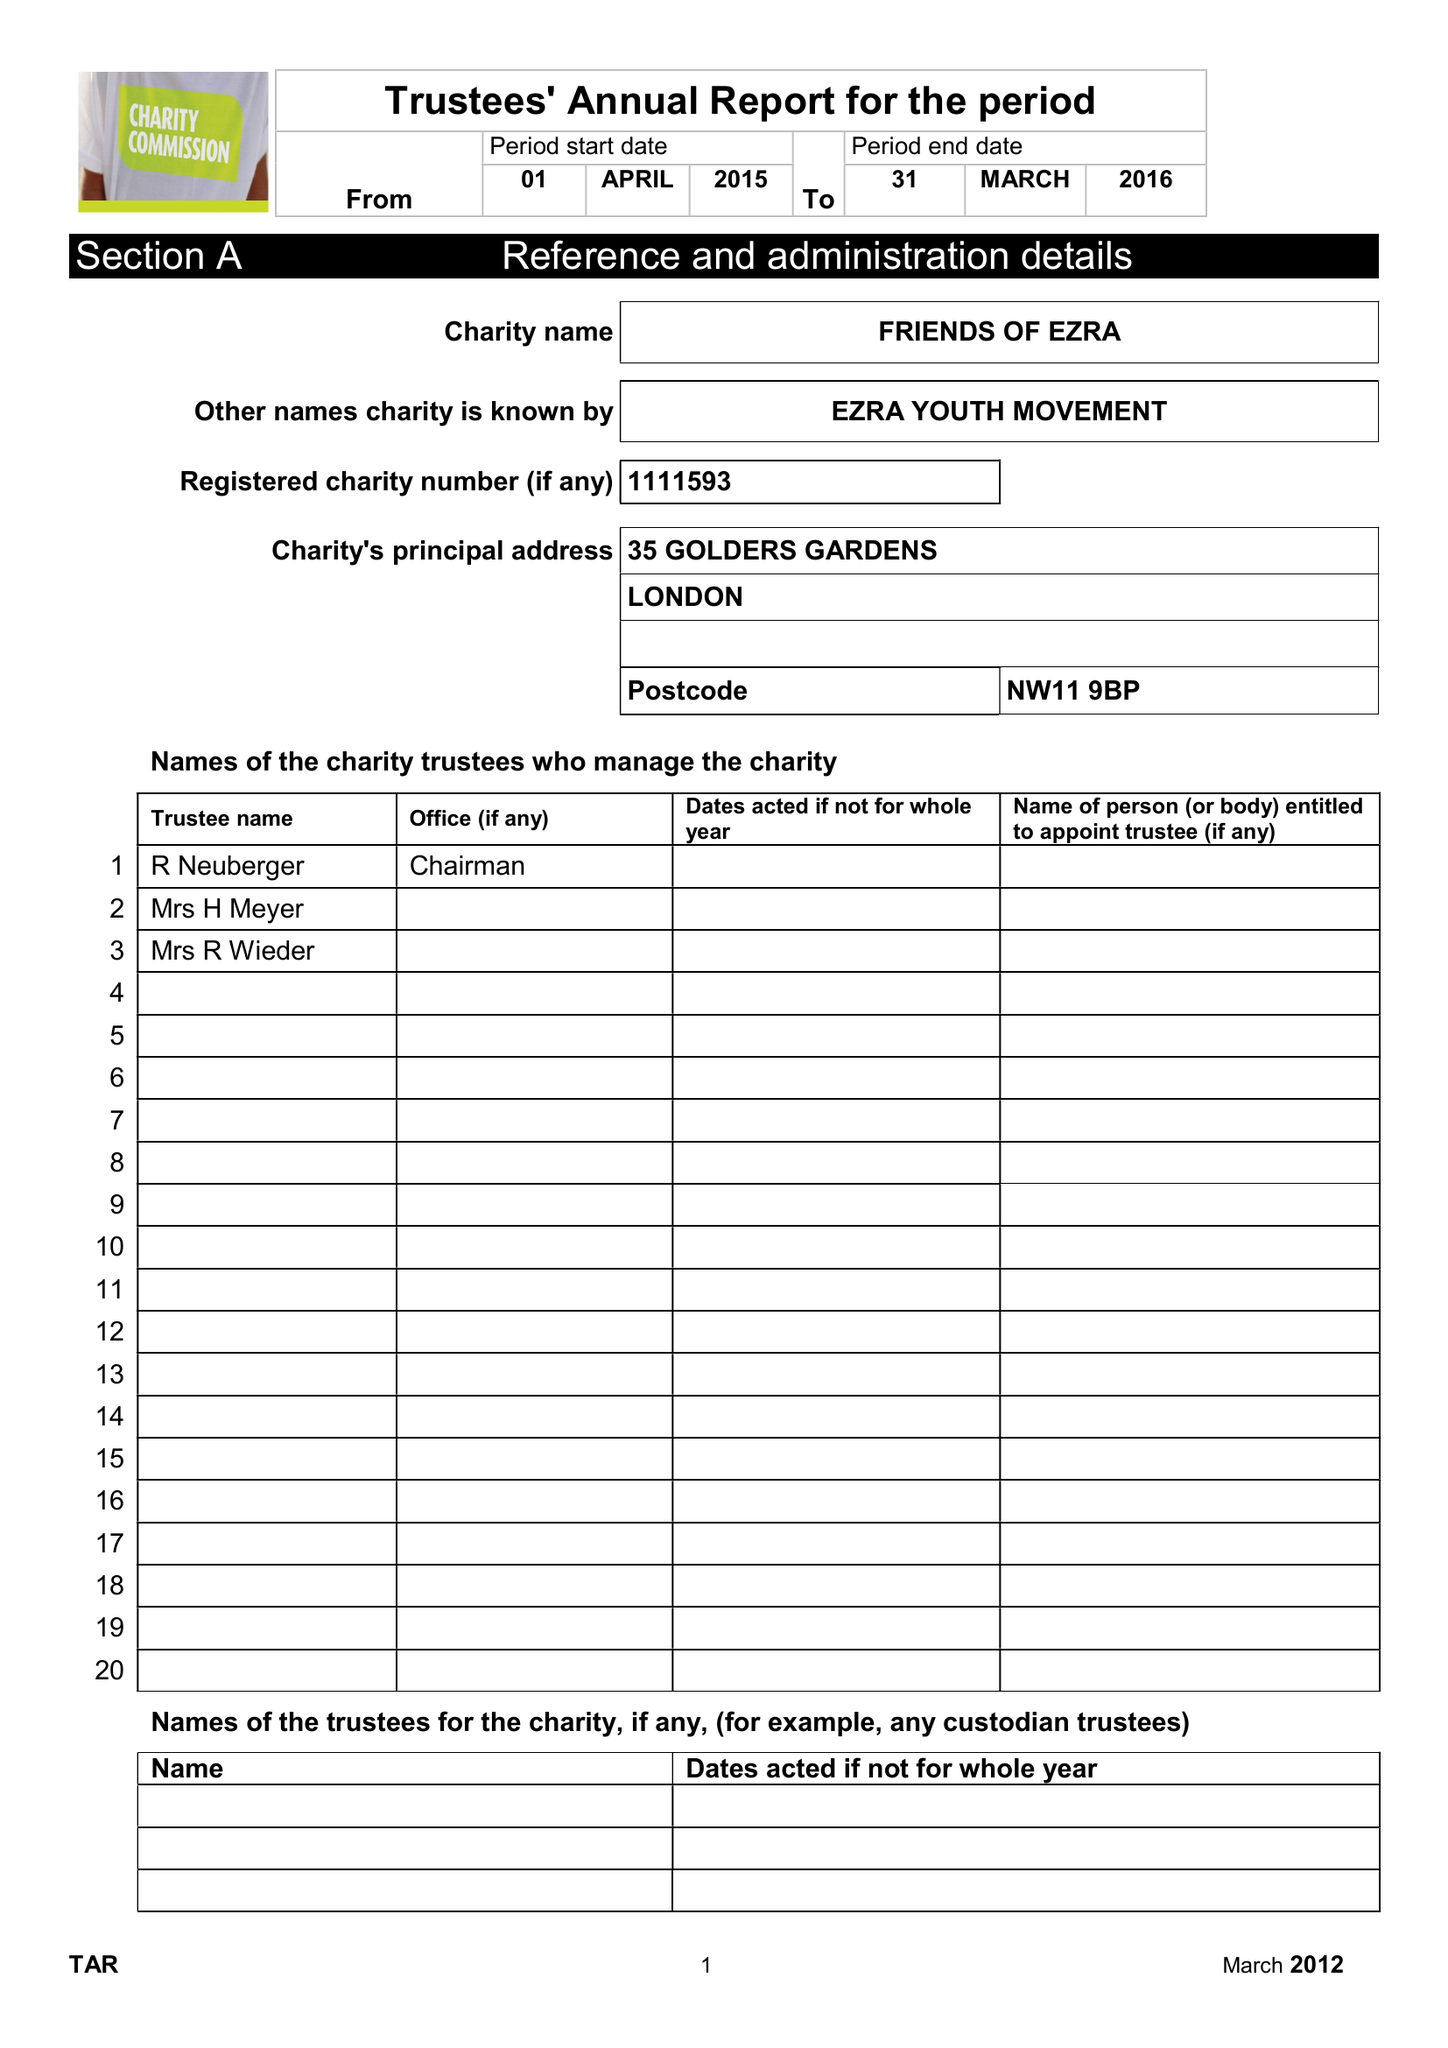What is the value for the address__post_town?
Answer the question using a single word or phrase. LONDON 